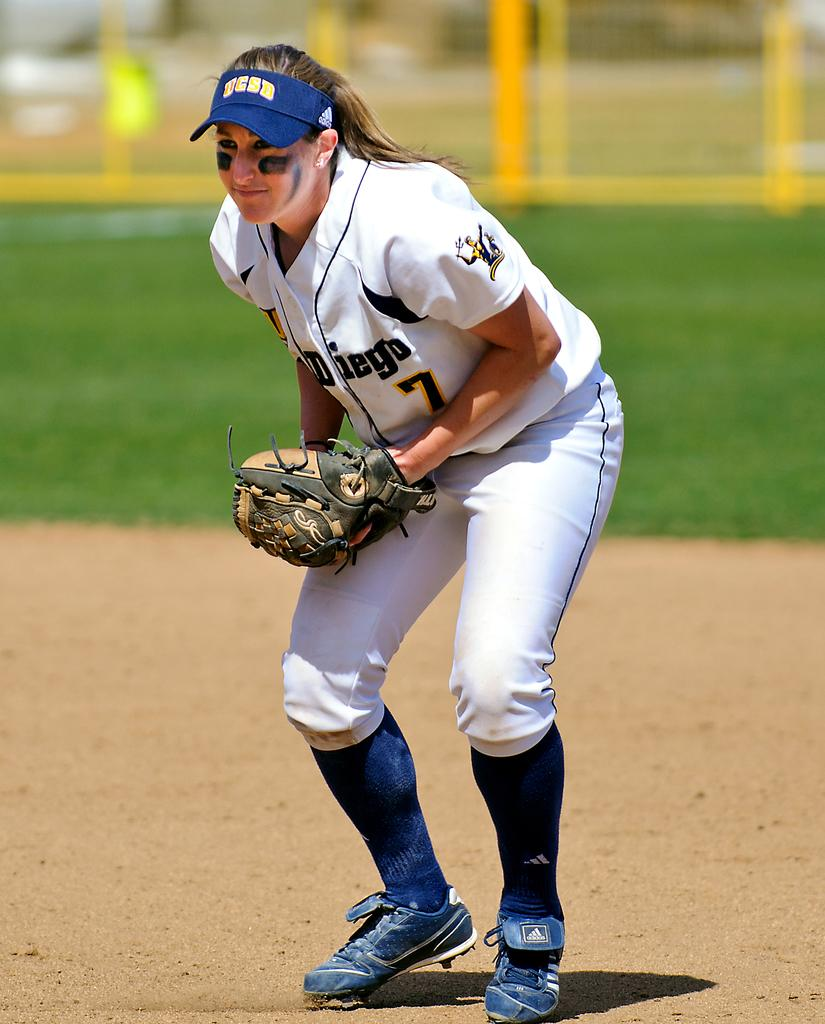Provide a one-sentence caption for the provided image. A girl is wearing a softball uniform with the number 7 on it. 